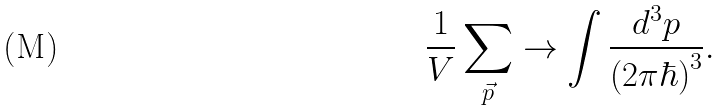<formula> <loc_0><loc_0><loc_500><loc_500>\frac { 1 } { V } \sum _ { \vec { p } } \to \int \frac { d ^ { 3 } p } { ( 2 \pi \hbar { ) } ^ { 3 } } .</formula> 